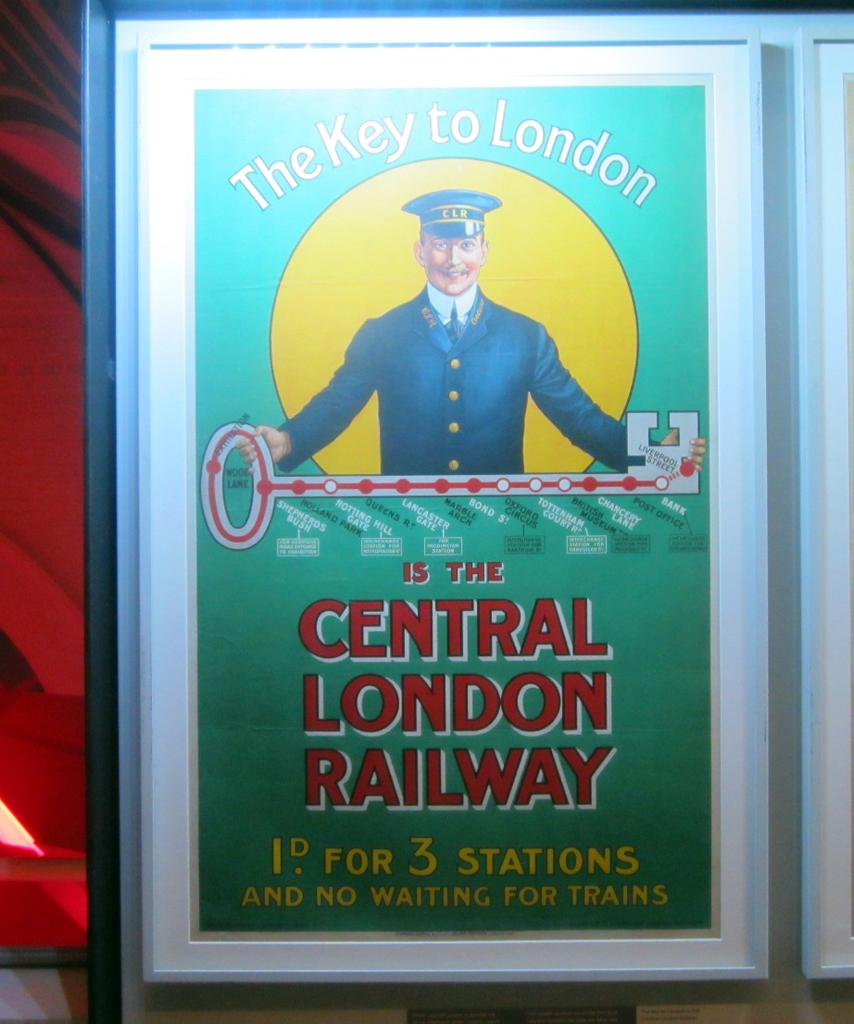<image>
Create a compact narrative representing the image presented. A poster advertising The Central London Railway cost 1d for 3 stations. 